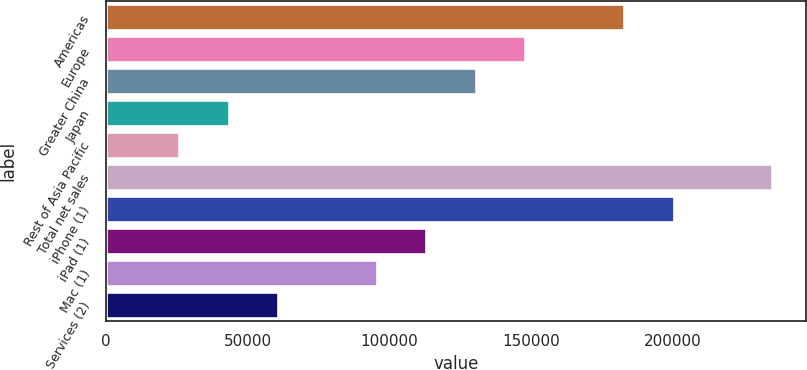<chart> <loc_0><loc_0><loc_500><loc_500><bar_chart><fcel>Americas<fcel>Europe<fcel>Greater China<fcel>Japan<fcel>Rest of Asia Pacific<fcel>Total net sales<fcel>iPhone (1)<fcel>iPad (1)<fcel>Mac (1)<fcel>Services (2)<nl><fcel>182795<fcel>147912<fcel>130470<fcel>43262.2<fcel>25820.6<fcel>235120<fcel>200237<fcel>113029<fcel>95587<fcel>60703.8<nl></chart> 